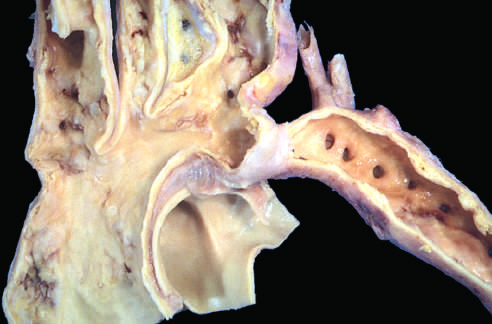what manifest later in life than preductal coarctations?
Answer the question using a single word or phrase. Lesions 